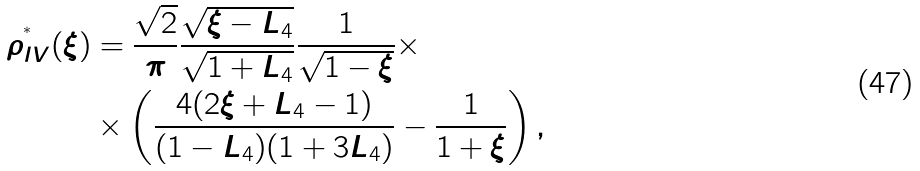<formula> <loc_0><loc_0><loc_500><loc_500>\rho ^ { ^ { * } } _ { I V } ( \xi ) & = \frac { \sqrt { 2 } } { \pi } \frac { \sqrt { \xi - L _ { 4 } } } { \sqrt { 1 + L _ { 4 } } } \frac { 1 } { \sqrt { 1 - \xi } } \times \\ & \times \left ( \frac { 4 ( 2 \xi + L _ { 4 } - 1 ) } { ( 1 - L _ { 4 } ) ( 1 + 3 L _ { 4 } ) } - \frac { 1 } { 1 + \xi } \right ) ,</formula> 